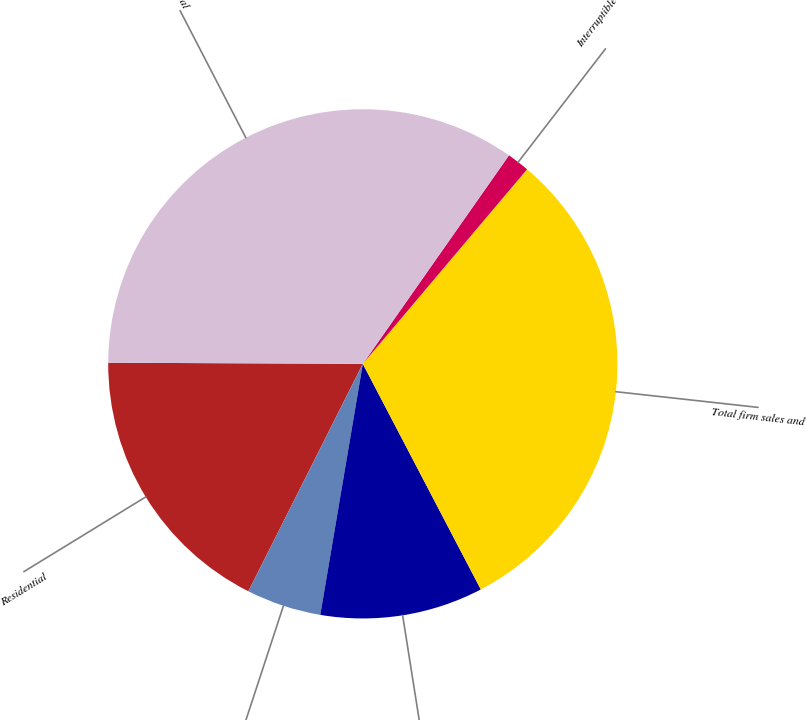Convert chart to OTSL. <chart><loc_0><loc_0><loc_500><loc_500><pie_chart><fcel>Residential<fcel>General<fcel>Firm transportation<fcel>Total firm sales and<fcel>Interruptible sales<fcel>Total<nl><fcel>17.65%<fcel>4.75%<fcel>10.34%<fcel>31.17%<fcel>1.43%<fcel>34.66%<nl></chart> 